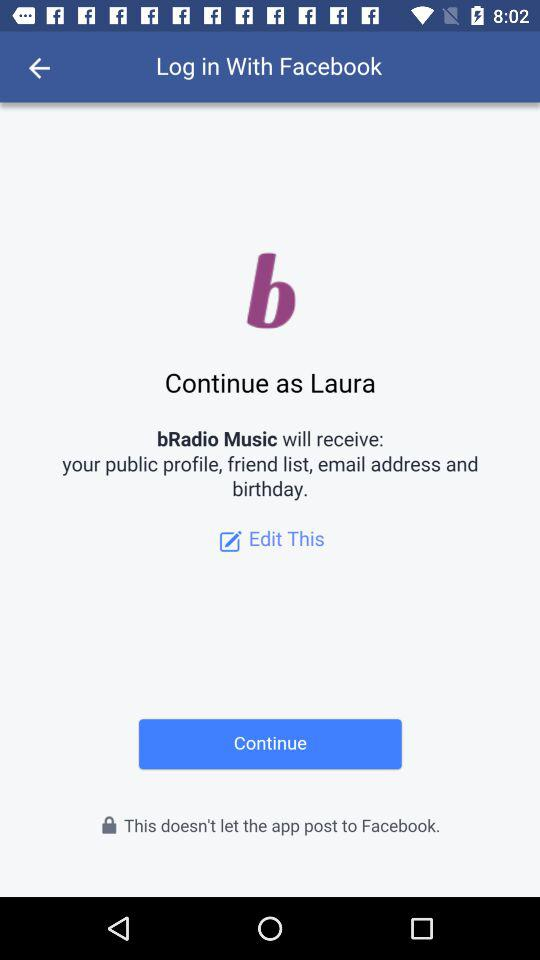What is the user name? The user name is Laura. 